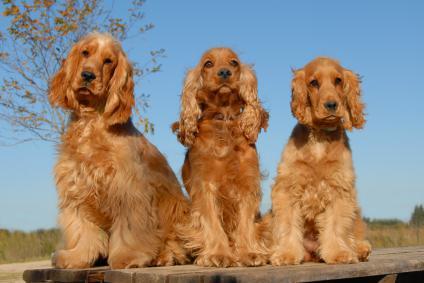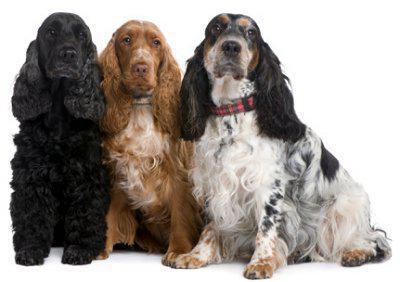The first image is the image on the left, the second image is the image on the right. Considering the images on both sides, is "There are at most four dogs." valid? Answer yes or no. No. The first image is the image on the left, the second image is the image on the right. Given the left and right images, does the statement "At least one half of the dogs have their mouths open." hold true? Answer yes or no. No. 